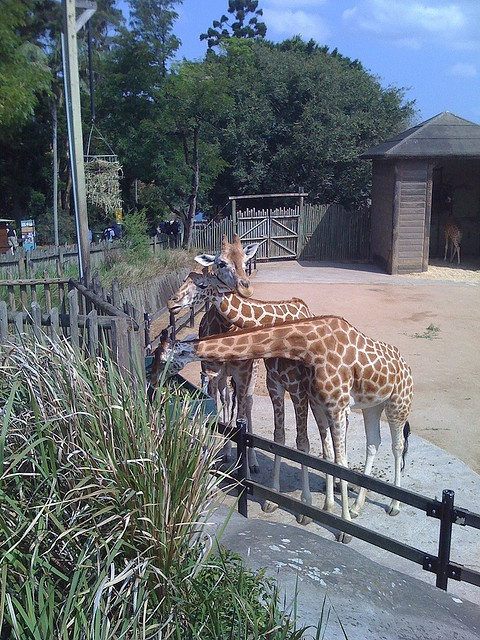Describe the objects in this image and their specific colors. I can see giraffe in black, gray, darkgray, and lightgray tones, giraffe in black, gray, and darkgray tones, giraffe in black, gray, darkgray, and lightgray tones, giraffe in black and gray tones, and people in black, darkgray, navy, and gray tones in this image. 